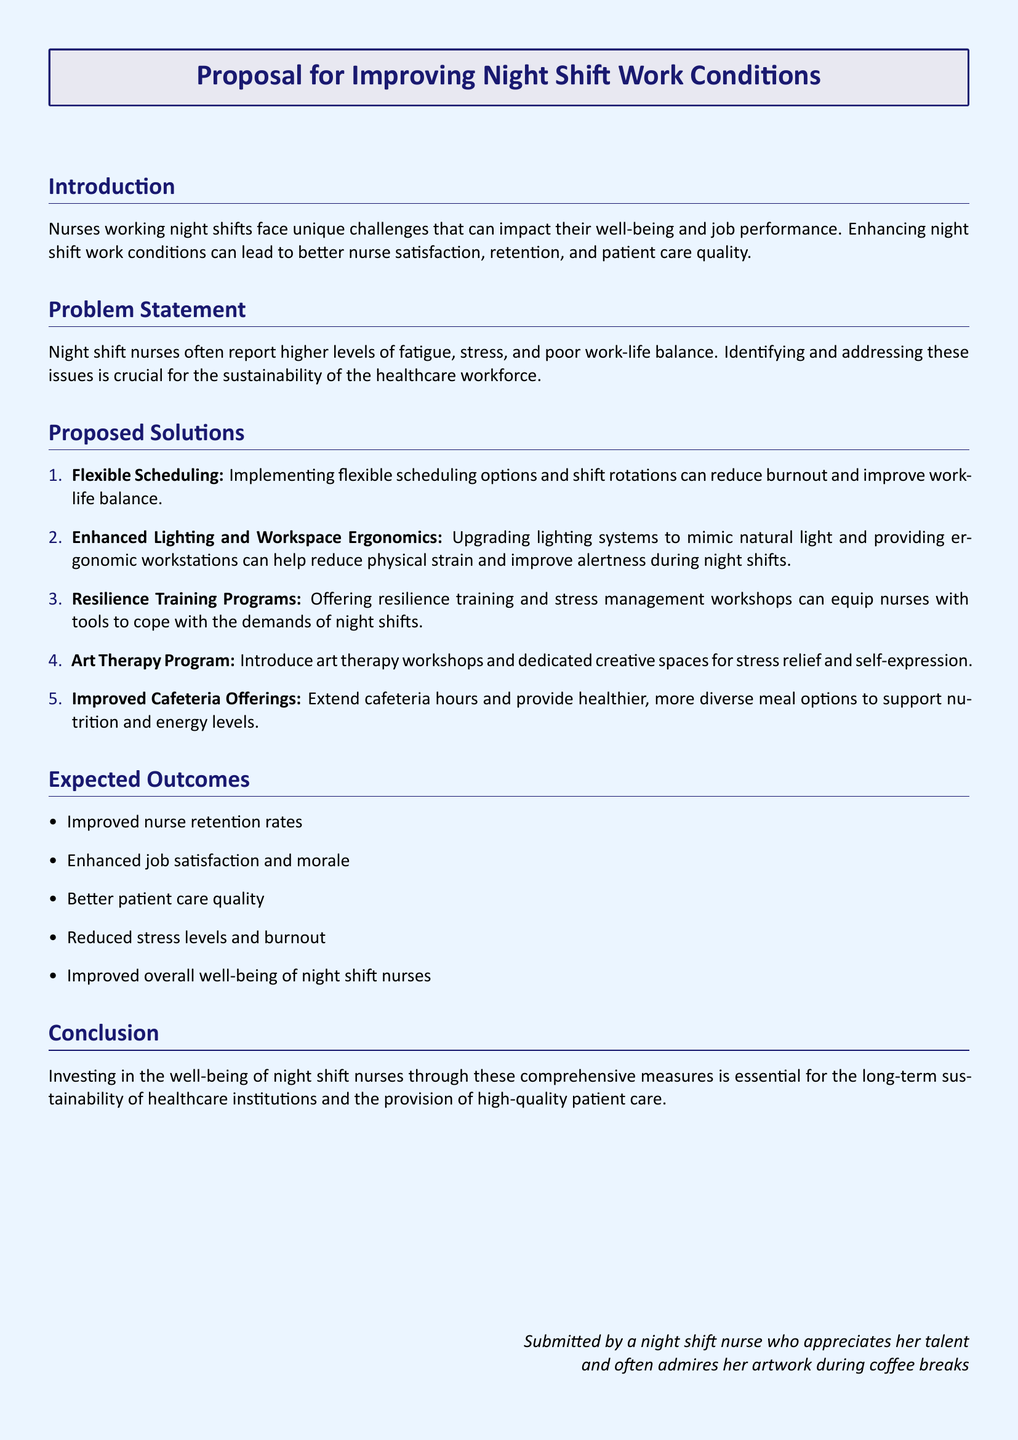What is the title of the proposal? The title is the main heading of the document, which states the focus of the proposal.
Answer: Proposal for Improving Night Shift Work Conditions What are the unique challenges faced by night shift nurses? The document identifies specific difficulties that impact night shift nurses.
Answer: Fatigue, stress, and poor work-life balance How many proposed solutions are included in the proposal? The total number of solutions is listed in the 'Proposed Solutions' section.
Answer: Five What is one expected outcome of improving night shift work conditions? The expected outcomes are listed in a bullet point format in the document.
Answer: Improved nurse retention rates What is the proposed solution that involves creativity? The document mentions solutions aimed at enhancing creativity for stress relief.
Answer: Art Therapy Program What specific training is suggested to help nurses cope with night shift demands? The document specifies certain types of training programs in the proposed solutions.
Answer: Resilience training What is the main focus of the proposal? The primary intent of the document can be gleaned from the introduction and title.
Answer: Improving night shift work conditions Who submitted the proposal? The document identifies the individual who prepared and submitted the proposal in the conclusion.
Answer: A night shift nurse who appreciates her talent and often admires her artwork during coffee breaks 